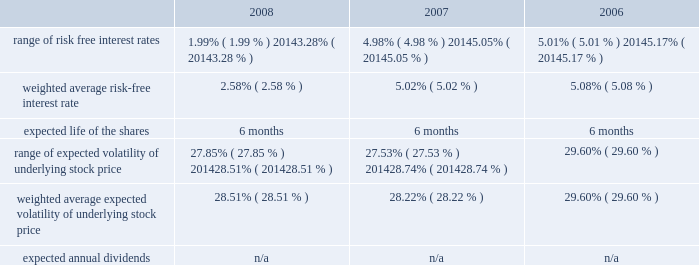American tower corporation and subsidiaries notes to consolidated financial statements 2014 ( continued ) from december 1 through may 31 of each year .
During the 2008 , 2007 and 2006 offering periods employees purchased 55764 , 48886 and 53210 shares , respectively , at weighted average prices per share of $ 30.08 , $ 33.93 and $ 24.98 , respectively .
The fair value of the espp offerings is estimated on the offering period commencement date using a black-scholes pricing model with the expense recognized over the expected life , which is the six month offering period over which employees accumulate payroll deductions to purchase the company 2019s common stock .
The weighted average fair value for the espp shares purchased during 2008 , 2007 and 2006 were $ 7.89 , $ 9.09 and $ 6.79 , respectively .
At december 31 , 2008 , 8.8 million shares remain reserved for future issuance under the plan .
Key assumptions used to apply this pricing model for the years ended december 31 , are as follows: .
13 .
Stockholders 2019 equity warrants 2014in january 2003 , the company issued warrants to purchase approximately 11.4 million shares of its common stock in connection with an offering of 808000 units , each consisting of $ 1000 principal amount at maturity of ati 12.25% ( 12.25 % ) senior subordinated discount notes due 2008 and a warrant to purchase 14.0953 shares of the company 2019s common stock .
These warrants became exercisable on january 29 , 2006 at an exercise price of $ 0.01 per share .
As these warrants expired on august 1 , 2008 , none were outstanding as of december 31 , in august 2005 , the company completed its merger with spectrasite , inc .
And assumed outstanding warrants to purchase shares of spectrasite , inc .
Common stock .
As of the merger completion date , each warrant was exercisable for two shares of spectrasite , inc .
Common stock at an exercise price of $ 32 per warrant .
Upon completion of the merger , each warrant to purchase shares of spectrasite , inc .
Common stock automatically converted into a warrant to purchase shares of the company 2019s common stock , such that upon exercise of each warrant , the holder has a right to receive 3.575 shares of the company 2019s common stock in lieu of each share of spectrasite , inc .
Common stock that would have been receivable under each assumed warrant prior to the merger .
Upon completion of the company 2019s merger with spectrasite , inc. , these warrants were exercisable for approximately 6.8 million shares of common stock .
Of these warrants , warrants to purchase approximately 1.8 million and 2.0 million shares of common stock remained outstanding as of december 31 , 2008 and 2007 , respectively .
These warrants will expire on february 10 , 2010 .
Stock repurchase programs 2014during the year ended december 31 , 2008 , the company repurchased an aggregate of approximately 18.3 million shares of its common stock for an aggregate of $ 697.1 million , including commissions and fees , pursuant to its publicly announced stock repurchase programs , as described below. .
What is the growth rate in the price of espp shares purchased from 2007 to 2008? 
Computations: ((7.89 - 9.09) / 9.09)
Answer: -0.13201. 